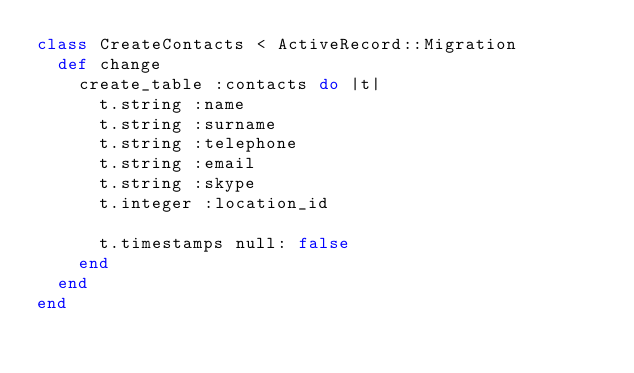Convert code to text. <code><loc_0><loc_0><loc_500><loc_500><_Ruby_>class CreateContacts < ActiveRecord::Migration
  def change
    create_table :contacts do |t|
      t.string :name
      t.string :surname
      t.string :telephone
      t.string :email
      t.string :skype
      t.integer :location_id

      t.timestamps null: false
    end
  end
end
</code> 